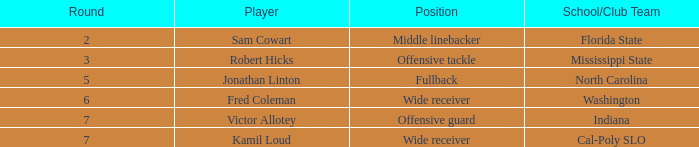Which school/club team holds a choice of 198? Indiana. 